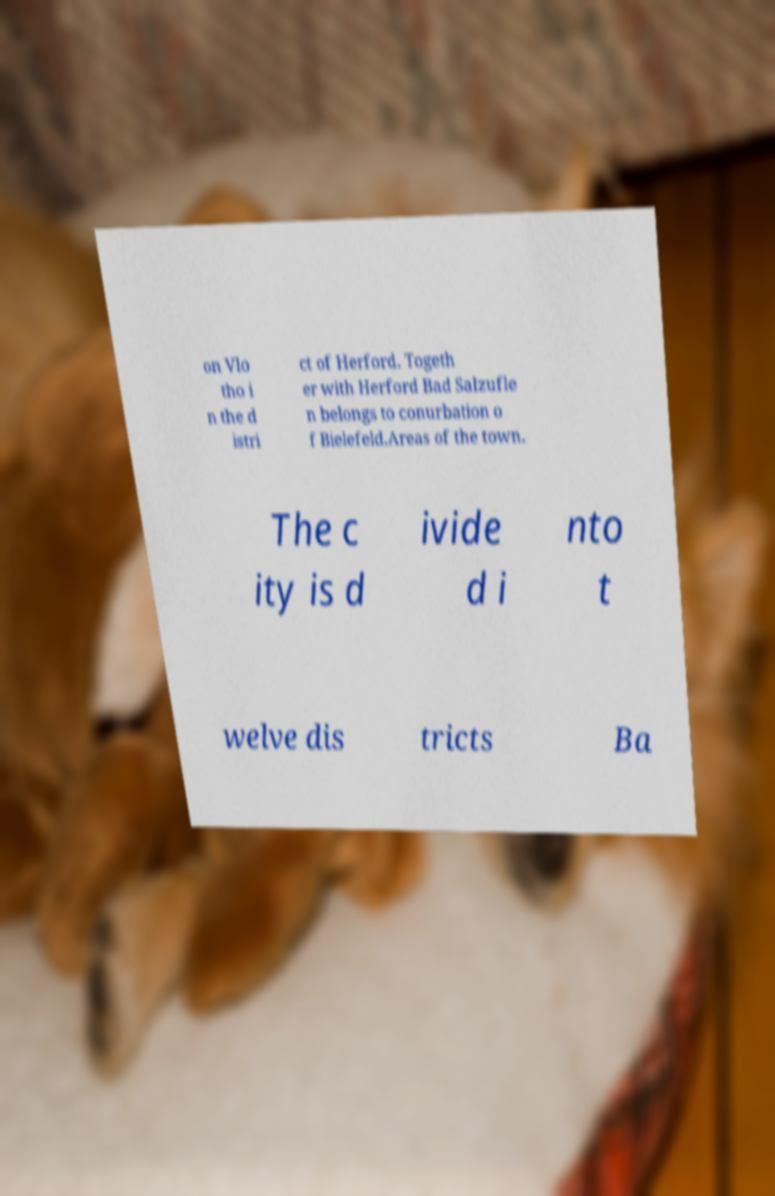Can you read and provide the text displayed in the image?This photo seems to have some interesting text. Can you extract and type it out for me? on Vlo tho i n the d istri ct of Herford. Togeth er with Herford Bad Salzufle n belongs to conurbation o f Bielefeld.Areas of the town. The c ity is d ivide d i nto t welve dis tricts Ba 